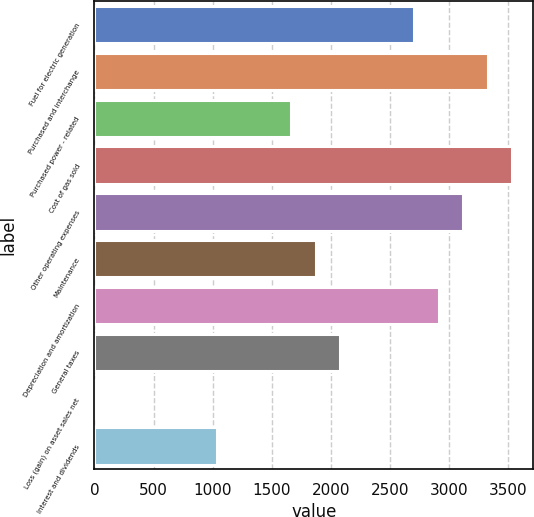Convert chart to OTSL. <chart><loc_0><loc_0><loc_500><loc_500><bar_chart><fcel>Fuel for electric generation<fcel>Purchased and interchange<fcel>Purchased power - related<fcel>Cost of gas sold<fcel>Other operating expenses<fcel>Maintenance<fcel>Depreciation and amortization<fcel>General taxes<fcel>Loss (gain) on asset sales net<fcel>Interest and dividends<nl><fcel>2702.4<fcel>3325.8<fcel>1663.4<fcel>3533.6<fcel>3118<fcel>1871.2<fcel>2910.2<fcel>2079<fcel>1<fcel>1040<nl></chart> 